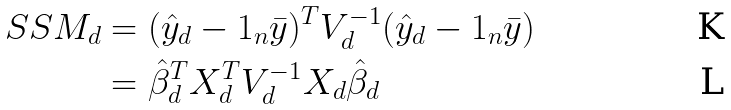Convert formula to latex. <formula><loc_0><loc_0><loc_500><loc_500>S S M _ { d } & = ( \hat { y } _ { d } - 1 _ { n } \bar { y } ) ^ { T } V _ { d } ^ { - 1 } ( \hat { y } _ { d } - 1 _ { n } \bar { y } ) \\ & = \hat { \beta } _ { d } ^ { T } X _ { d } ^ { T } V _ { d } ^ { - 1 } X _ { d } \hat { \beta } _ { d }</formula> 